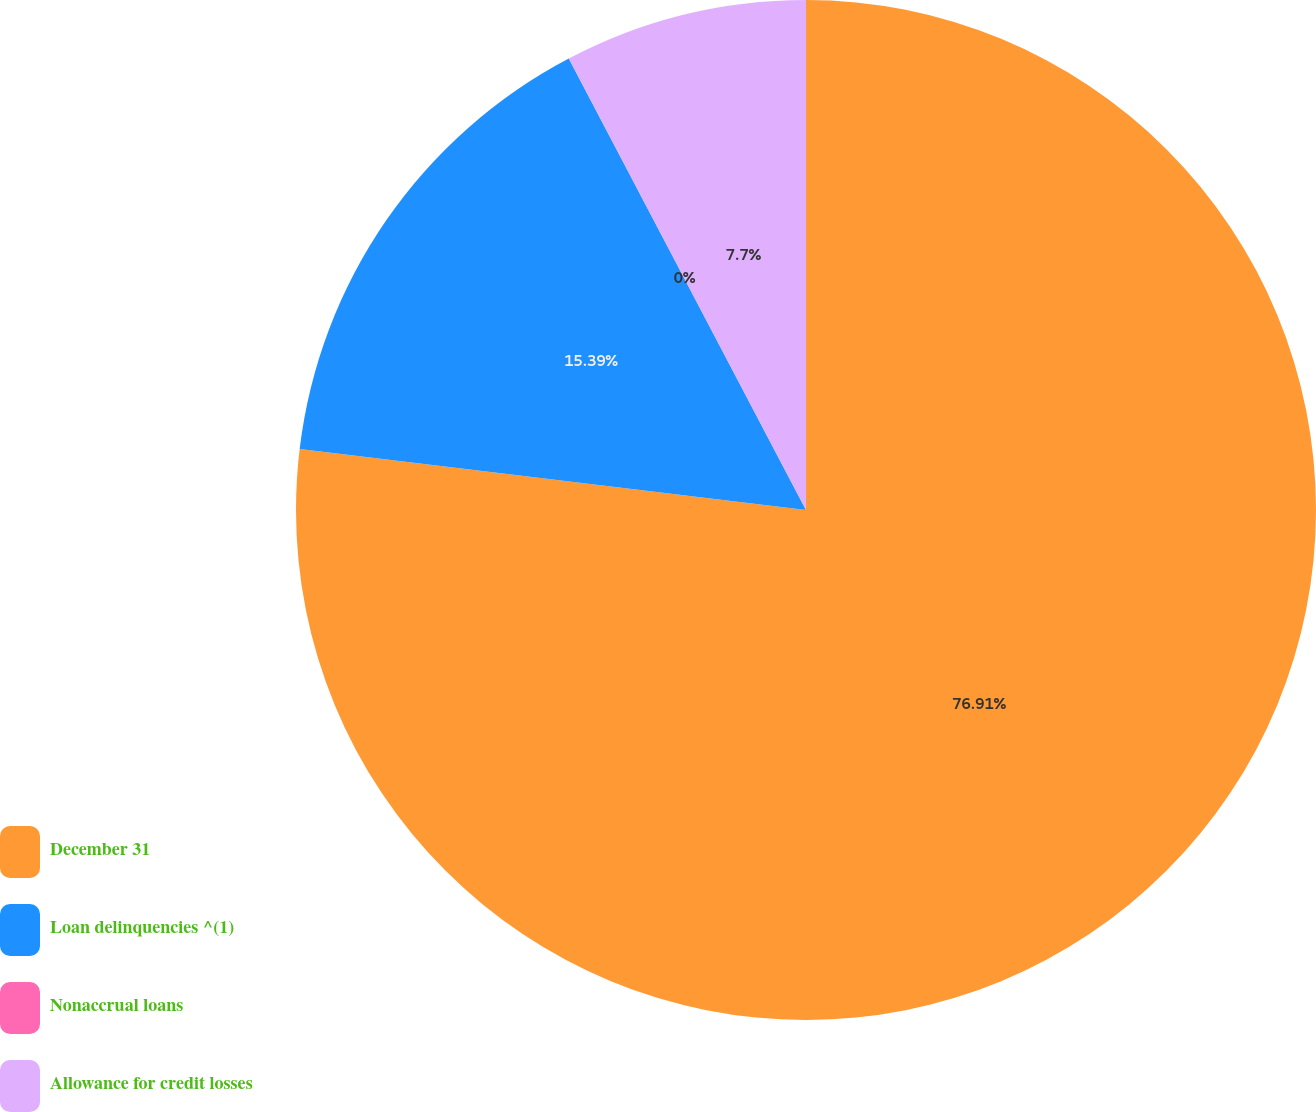Convert chart to OTSL. <chart><loc_0><loc_0><loc_500><loc_500><pie_chart><fcel>December 31<fcel>Loan delinquencies ^(1)<fcel>Nonaccrual loans<fcel>Allowance for credit losses<nl><fcel>76.91%<fcel>15.39%<fcel>0.0%<fcel>7.7%<nl></chart> 